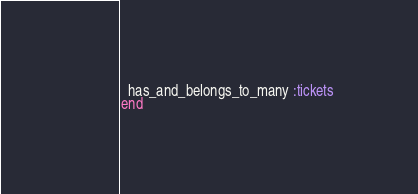Convert code to text. <code><loc_0><loc_0><loc_500><loc_500><_Ruby_>  has_and_belongs_to_many :tickets
end</code> 